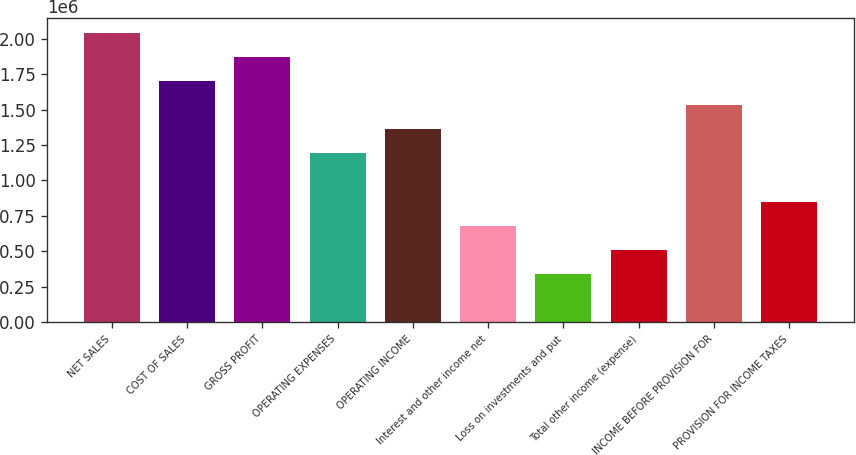<chart> <loc_0><loc_0><loc_500><loc_500><bar_chart><fcel>NET SALES<fcel>COST OF SALES<fcel>GROSS PROFIT<fcel>OPERATING EXPENSES<fcel>OPERATING INCOME<fcel>Interest and other income net<fcel>Loss on investments and put<fcel>Total other income (expense)<fcel>INCOME BEFORE PROVISION FOR<fcel>PROVISION FOR INCOME TAXES<nl><fcel>2.04388e+06<fcel>1.70323e+06<fcel>1.87355e+06<fcel>1.19226e+06<fcel>1.36258e+06<fcel>681293<fcel>340647<fcel>510970<fcel>1.53291e+06<fcel>851616<nl></chart> 